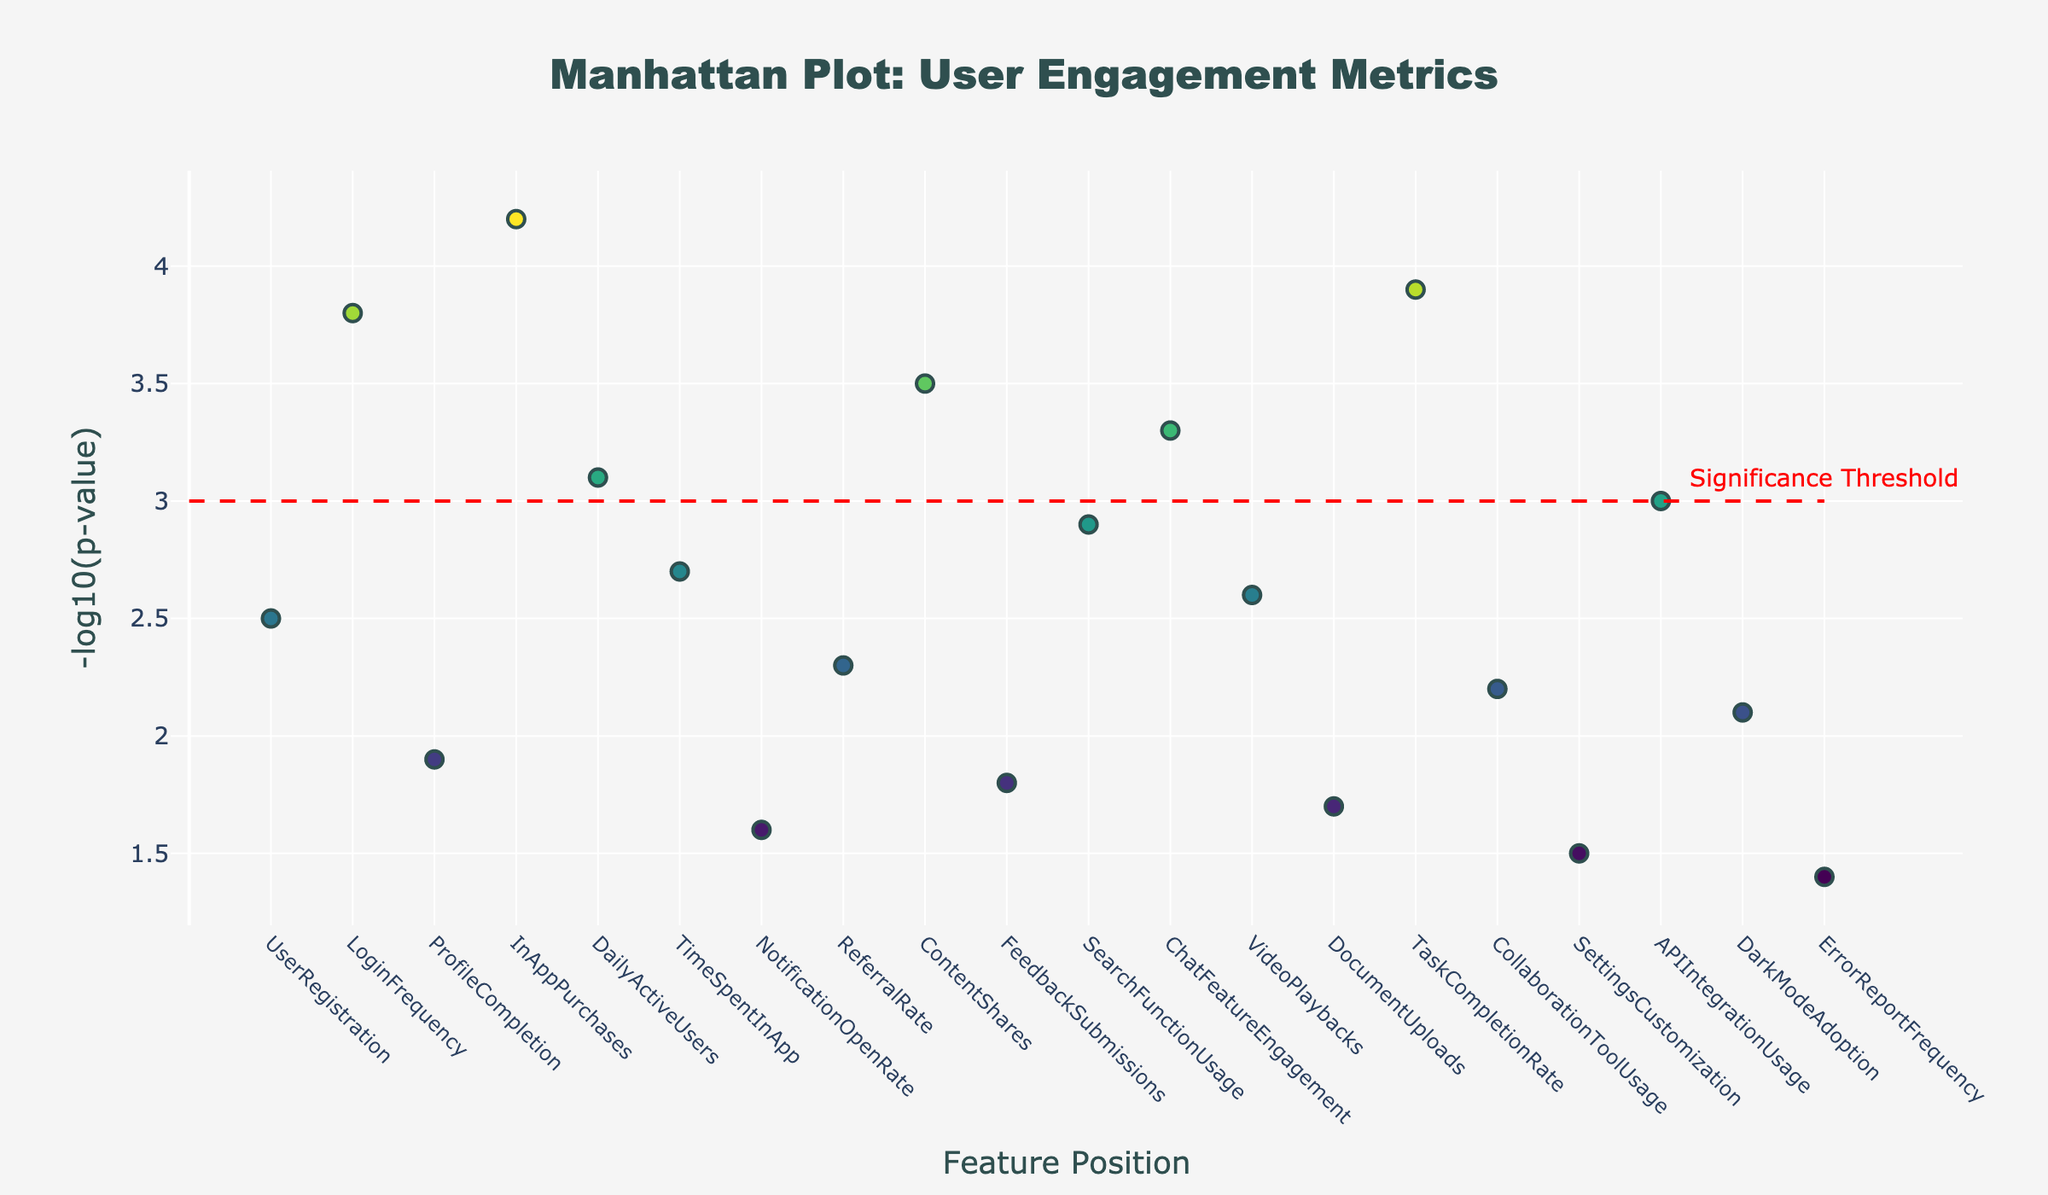What's the title of the plot? The title is written at the top center of the plot. It reads "Manhattan Plot: User Engagement Metrics" in large, bold font.
Answer: Manhattan Plot: User Engagement Metrics How many features have a -log10(p-value) greater than 3? Look for markers above the significance threshold line set at y = 3. There are five markers above this line: LoginFrequency, InAppPurchases, DailyActiveUsers, ContentShares, and TaskCompletionRate.
Answer: Five Which feature has the highest -log10(p-value)? Scan the y-axis for the highest marker. The position with the highest value is at Position 4, corresponding to the feature InAppPurchases.
Answer: InAppPurchases What is the -log10(p-value) for TimeSpentInApp? Find the position of the feature TimeSpentInApp on the x-axis, which is Position 6. Then locate its marker on the y-axis, which corresponds to a -log10(p-value) of 2.7.
Answer: 2.7 Which feature appears to have the lowest statistical significance? The feature with the smallest marker on the y-axis corresponds to the lowest -log10(p-value). This is at Position 20, corresponding to ErrorReportFrequency, with the lowest y-value.
Answer: ErrorReportFrequency What is the average -log10(p-value) for features that are below the significance threshold? Identify all markers below y=3 and their values: UserRegistration (2.5), ProfileCompletion (1.9), NotificationOpenRate (1.6), ReferralRate (2.3), FeedbackSubmissions (1.8), SearchFunctionUsage (2.9), VideoPlaybacks (2.6), DocumentUploads (1.7), CollaborationToolUsage (2.2), SettingsCustomization (1.5), APIIntegrationUsage (3.0), DarkModeAdoption (2.1), ErrorReportFrequency (1.4). Sum these values and divide by the number of features: (2.5+1.9+1.6+2.3+1.8+2.9+2.6+1.7+2.2+1.5+3.0+2.1+1.4)/13.
Answer: 2.07 Which features have similar -log10(p-values) to each other? Compare the y-axis values of features to find those with similar heights. LoginFrequency (3.8) and TaskCompletionRate (3.9) are close to each other, as are DailyActiveUsers (3.1) and APIIntegrationUsage (3.0).
Answer: Several pairs, including LoginFrequency and TaskCompletionRate, DailyActiveUsers and APIIntegrationUsage How does the significance of DailyActiveUsers compare to ErrorReportFrequency? Compare their positions on the y-axis. DailyActiveUsers is at Position 5 with a -log10(p-value) of 3.1, well above the significance threshold, while ErrorReportFrequency is at Position 20 with a very low -log10(p-value) of 1.4.
Answer: DailyActiveUsers is much more significant than ErrorReportFrequency 